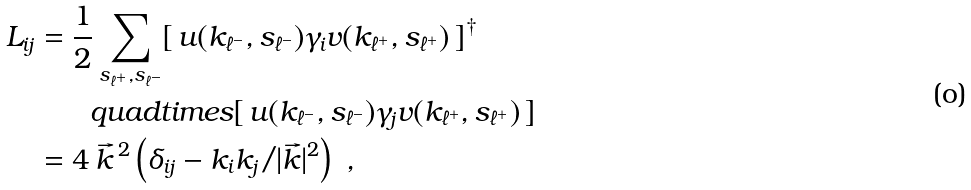Convert formula to latex. <formula><loc_0><loc_0><loc_500><loc_500>L _ { i j } & = \frac { 1 } { 2 } \sum _ { s _ { \ell ^ { + } } , s _ { \ell ^ { - } } } [ \, u ( k _ { \ell ^ { - } } , s _ { \ell ^ { - } } ) \gamma _ { i } v ( k _ { \ell ^ { + } } , s _ { \ell ^ { + } } ) \, ] ^ { \dagger } \\ & \quad \ \ \ q u a d t i m e s [ \, u ( k _ { \ell ^ { - } } , s _ { \ell ^ { - } } ) \gamma _ { j } v ( k _ { \ell ^ { + } } , s _ { \ell ^ { + } } ) \, ] \\ & = 4 \, \vec { k } ^ { \, 2 } \left ( \delta _ { i j } - k _ { i } k _ { j } / | \vec { k } | ^ { 2 } \right ) \ ,</formula> 